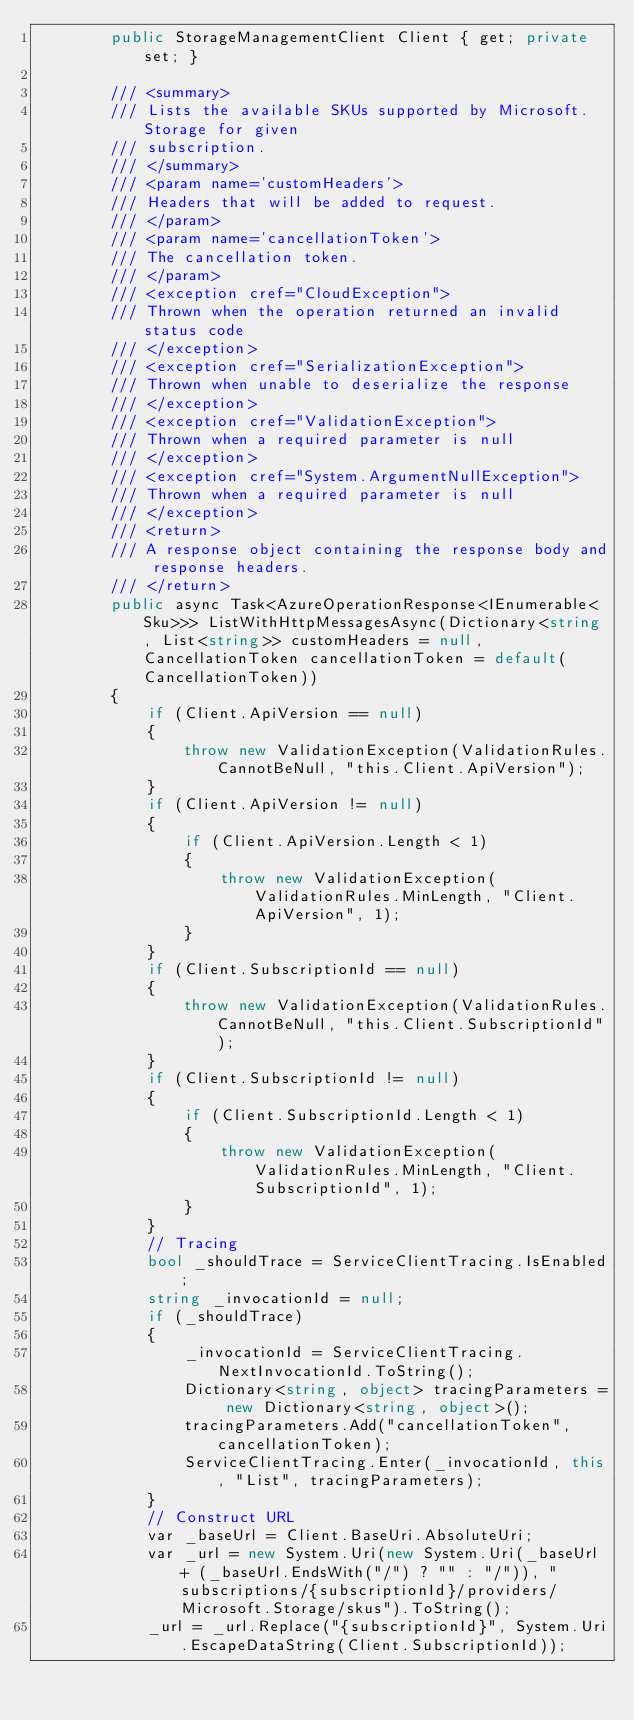<code> <loc_0><loc_0><loc_500><loc_500><_C#_>        public StorageManagementClient Client { get; private set; }

        /// <summary>
        /// Lists the available SKUs supported by Microsoft.Storage for given
        /// subscription.
        /// </summary>
        /// <param name='customHeaders'>
        /// Headers that will be added to request.
        /// </param>
        /// <param name='cancellationToken'>
        /// The cancellation token.
        /// </param>
        /// <exception cref="CloudException">
        /// Thrown when the operation returned an invalid status code
        /// </exception>
        /// <exception cref="SerializationException">
        /// Thrown when unable to deserialize the response
        /// </exception>
        /// <exception cref="ValidationException">
        /// Thrown when a required parameter is null
        /// </exception>
        /// <exception cref="System.ArgumentNullException">
        /// Thrown when a required parameter is null
        /// </exception>
        /// <return>
        /// A response object containing the response body and response headers.
        /// </return>
        public async Task<AzureOperationResponse<IEnumerable<Sku>>> ListWithHttpMessagesAsync(Dictionary<string, List<string>> customHeaders = null, CancellationToken cancellationToken = default(CancellationToken))
        {
            if (Client.ApiVersion == null)
            {
                throw new ValidationException(ValidationRules.CannotBeNull, "this.Client.ApiVersion");
            }
            if (Client.ApiVersion != null)
            {
                if (Client.ApiVersion.Length < 1)
                {
                    throw new ValidationException(ValidationRules.MinLength, "Client.ApiVersion", 1);
                }
            }
            if (Client.SubscriptionId == null)
            {
                throw new ValidationException(ValidationRules.CannotBeNull, "this.Client.SubscriptionId");
            }
            if (Client.SubscriptionId != null)
            {
                if (Client.SubscriptionId.Length < 1)
                {
                    throw new ValidationException(ValidationRules.MinLength, "Client.SubscriptionId", 1);
                }
            }
            // Tracing
            bool _shouldTrace = ServiceClientTracing.IsEnabled;
            string _invocationId = null;
            if (_shouldTrace)
            {
                _invocationId = ServiceClientTracing.NextInvocationId.ToString();
                Dictionary<string, object> tracingParameters = new Dictionary<string, object>();
                tracingParameters.Add("cancellationToken", cancellationToken);
                ServiceClientTracing.Enter(_invocationId, this, "List", tracingParameters);
            }
            // Construct URL
            var _baseUrl = Client.BaseUri.AbsoluteUri;
            var _url = new System.Uri(new System.Uri(_baseUrl + (_baseUrl.EndsWith("/") ? "" : "/")), "subscriptions/{subscriptionId}/providers/Microsoft.Storage/skus").ToString();
            _url = _url.Replace("{subscriptionId}", System.Uri.EscapeDataString(Client.SubscriptionId));</code> 